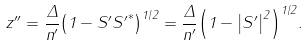Convert formula to latex. <formula><loc_0><loc_0><loc_500><loc_500>z ^ { \prime \prime } = \frac { \Delta } { n ^ { \prime } } { \left ( 1 - S ^ { \prime } { S ^ { \prime } } ^ { * } \right ) } ^ { 1 / 2 } = \frac { \Delta } { n ^ { \prime } } { \left ( 1 - { \left | S ^ { \prime } \right | } ^ { 2 } \right ) } ^ { 1 / 2 } .</formula> 